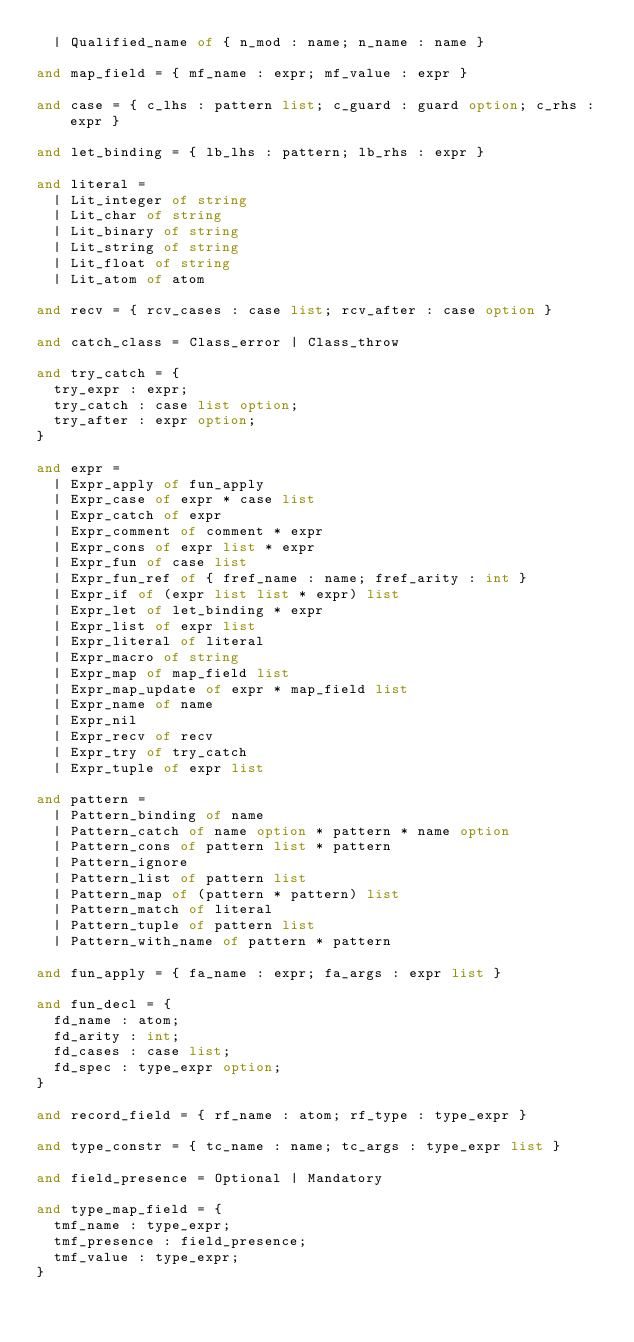Convert code to text. <code><loc_0><loc_0><loc_500><loc_500><_OCaml_>  | Qualified_name of { n_mod : name; n_name : name }

and map_field = { mf_name : expr; mf_value : expr }

and case = { c_lhs : pattern list; c_guard : guard option; c_rhs : expr }

and let_binding = { lb_lhs : pattern; lb_rhs : expr }

and literal =
  | Lit_integer of string
  | Lit_char of string
  | Lit_binary of string
  | Lit_string of string
  | Lit_float of string
  | Lit_atom of atom

and recv = { rcv_cases : case list; rcv_after : case option }

and catch_class = Class_error | Class_throw

and try_catch = {
  try_expr : expr;
  try_catch : case list option;
  try_after : expr option;
}

and expr =
  | Expr_apply of fun_apply
  | Expr_case of expr * case list
  | Expr_catch of expr
  | Expr_comment of comment * expr
  | Expr_cons of expr list * expr
  | Expr_fun of case list
  | Expr_fun_ref of { fref_name : name; fref_arity : int }
  | Expr_if of (expr list list * expr) list
  | Expr_let of let_binding * expr
  | Expr_list of expr list
  | Expr_literal of literal
  | Expr_macro of string
  | Expr_map of map_field list
  | Expr_map_update of expr * map_field list
  | Expr_name of name
  | Expr_nil
  | Expr_recv of recv
  | Expr_try of try_catch
  | Expr_tuple of expr list

and pattern =
  | Pattern_binding of name
  | Pattern_catch of name option * pattern * name option
  | Pattern_cons of pattern list * pattern
  | Pattern_ignore
  | Pattern_list of pattern list
  | Pattern_map of (pattern * pattern) list
  | Pattern_match of literal
  | Pattern_tuple of pattern list
  | Pattern_with_name of pattern * pattern

and fun_apply = { fa_name : expr; fa_args : expr list }

and fun_decl = {
  fd_name : atom;
  fd_arity : int;
  fd_cases : case list;
  fd_spec : type_expr option;
}

and record_field = { rf_name : atom; rf_type : type_expr }

and type_constr = { tc_name : name; tc_args : type_expr list }

and field_presence = Optional | Mandatory

and type_map_field = {
  tmf_name : type_expr;
  tmf_presence : field_presence;
  tmf_value : type_expr;
}
</code> 